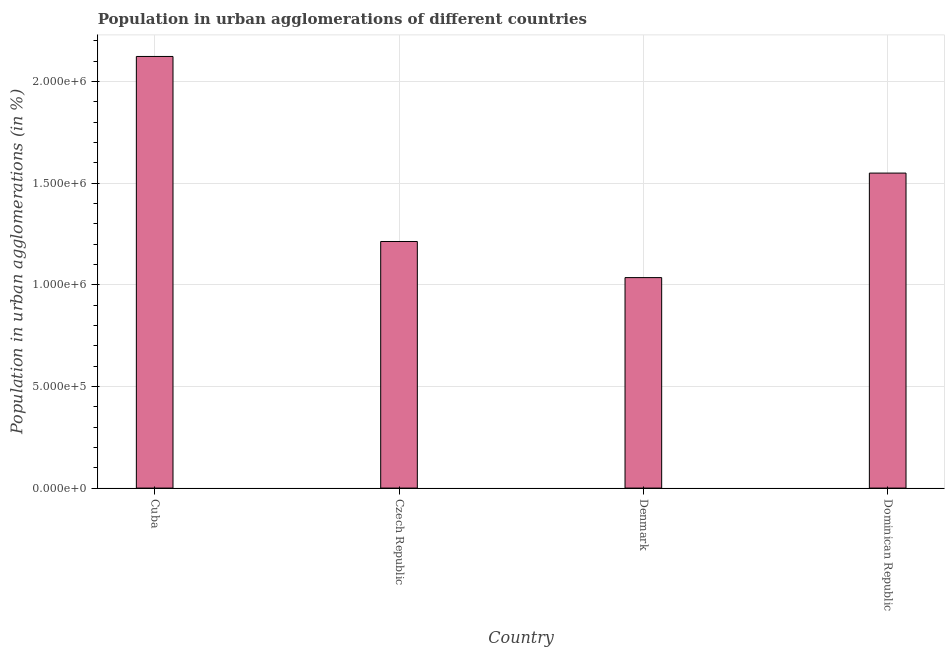Does the graph contain any zero values?
Make the answer very short. No. What is the title of the graph?
Your answer should be compact. Population in urban agglomerations of different countries. What is the label or title of the Y-axis?
Your answer should be compact. Population in urban agglomerations (in %). What is the population in urban agglomerations in Cuba?
Make the answer very short. 2.12e+06. Across all countries, what is the maximum population in urban agglomerations?
Keep it short and to the point. 2.12e+06. Across all countries, what is the minimum population in urban agglomerations?
Provide a succinct answer. 1.04e+06. In which country was the population in urban agglomerations maximum?
Ensure brevity in your answer.  Cuba. In which country was the population in urban agglomerations minimum?
Keep it short and to the point. Denmark. What is the sum of the population in urban agglomerations?
Provide a short and direct response. 5.92e+06. What is the difference between the population in urban agglomerations in Czech Republic and Dominican Republic?
Ensure brevity in your answer.  -3.36e+05. What is the average population in urban agglomerations per country?
Your response must be concise. 1.48e+06. What is the median population in urban agglomerations?
Provide a short and direct response. 1.38e+06. What is the difference between the highest and the second highest population in urban agglomerations?
Keep it short and to the point. 5.74e+05. Is the sum of the population in urban agglomerations in Czech Republic and Denmark greater than the maximum population in urban agglomerations across all countries?
Make the answer very short. Yes. What is the difference between the highest and the lowest population in urban agglomerations?
Give a very brief answer. 1.09e+06. How many bars are there?
Provide a succinct answer. 4. Are all the bars in the graph horizontal?
Provide a succinct answer. No. What is the Population in urban agglomerations (in %) in Cuba?
Offer a very short reply. 2.12e+06. What is the Population in urban agglomerations (in %) of Czech Republic?
Make the answer very short. 1.21e+06. What is the Population in urban agglomerations (in %) of Denmark?
Your answer should be compact. 1.04e+06. What is the Population in urban agglomerations (in %) in Dominican Republic?
Provide a short and direct response. 1.55e+06. What is the difference between the Population in urban agglomerations (in %) in Cuba and Czech Republic?
Your response must be concise. 9.10e+05. What is the difference between the Population in urban agglomerations (in %) in Cuba and Denmark?
Your answer should be very brief. 1.09e+06. What is the difference between the Population in urban agglomerations (in %) in Cuba and Dominican Republic?
Provide a succinct answer. 5.74e+05. What is the difference between the Population in urban agglomerations (in %) in Czech Republic and Denmark?
Give a very brief answer. 1.78e+05. What is the difference between the Population in urban agglomerations (in %) in Czech Republic and Dominican Republic?
Provide a succinct answer. -3.36e+05. What is the difference between the Population in urban agglomerations (in %) in Denmark and Dominican Republic?
Provide a succinct answer. -5.14e+05. What is the ratio of the Population in urban agglomerations (in %) in Cuba to that in Czech Republic?
Your answer should be compact. 1.75. What is the ratio of the Population in urban agglomerations (in %) in Cuba to that in Denmark?
Offer a very short reply. 2.05. What is the ratio of the Population in urban agglomerations (in %) in Cuba to that in Dominican Republic?
Your answer should be very brief. 1.37. What is the ratio of the Population in urban agglomerations (in %) in Czech Republic to that in Denmark?
Keep it short and to the point. 1.17. What is the ratio of the Population in urban agglomerations (in %) in Czech Republic to that in Dominican Republic?
Your response must be concise. 0.78. What is the ratio of the Population in urban agglomerations (in %) in Denmark to that in Dominican Republic?
Offer a very short reply. 0.67. 